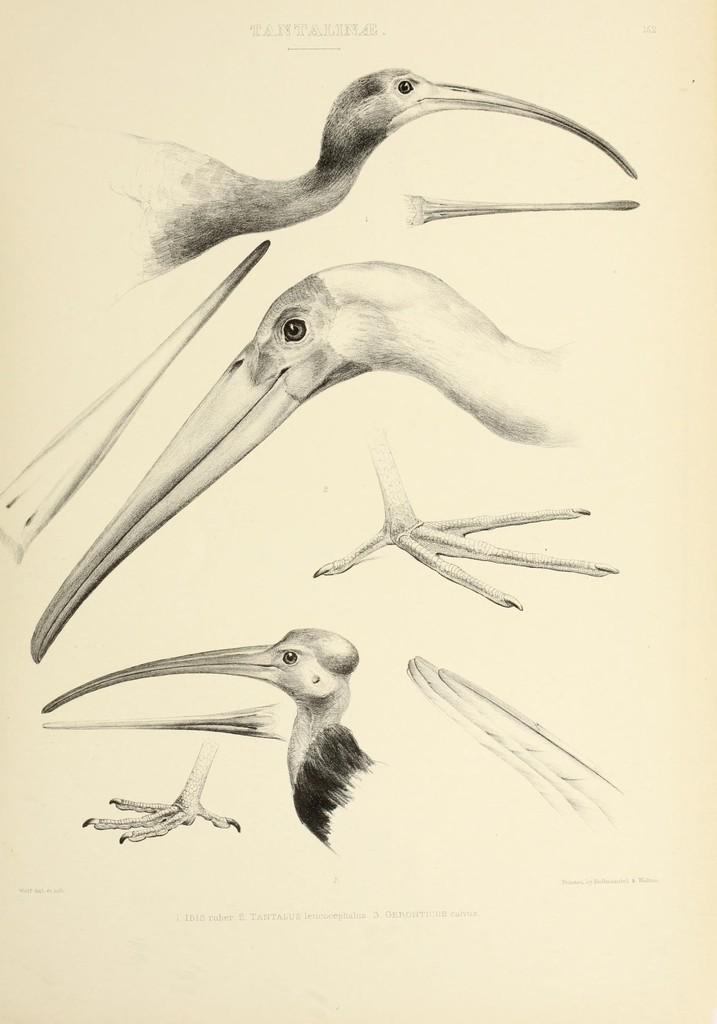Please provide a concise description of this image. In this I can see a white color paper which consists of the diagrams of birds. On the top of this image I can see some text. 